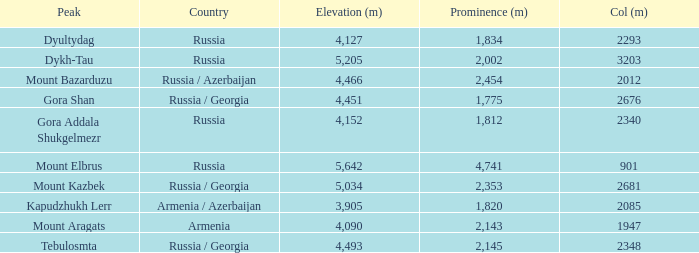What is the Col (m) of Peak Mount Aragats with an Elevation (m) larger than 3,905 and Prominence smaller than 2,143? None. 